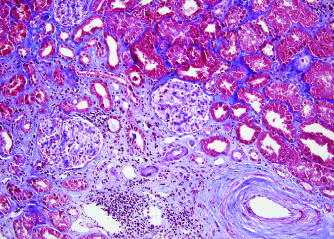s the embolus shown (bottom right)?
Answer the question using a single word or phrase. No 